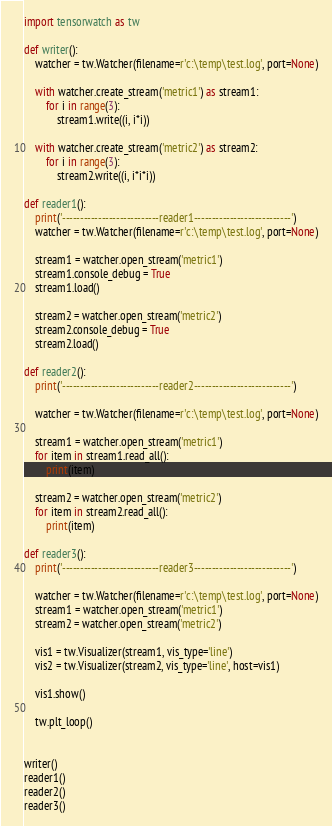Convert code to text. <code><loc_0><loc_0><loc_500><loc_500><_Python_>import tensorwatch as tw

def writer():
    watcher = tw.Watcher(filename=r'c:\temp\test.log', port=None)

    with watcher.create_stream('metric1') as stream1:
        for i in range(3):
            stream1.write((i, i*i))

    with watcher.create_stream('metric2') as stream2:
        for i in range(3):
            stream2.write((i, i*i*i))

def reader1():
    print('---------------------------reader1---------------------------')
    watcher = tw.Watcher(filename=r'c:\temp\test.log', port=None)

    stream1 = watcher.open_stream('metric1')
    stream1.console_debug = True
    stream1.load()

    stream2 = watcher.open_stream('metric2')
    stream2.console_debug = True
    stream2.load()

def reader2():
    print('---------------------------reader2---------------------------')

    watcher = tw.Watcher(filename=r'c:\temp\test.log', port=None)

    stream1 = watcher.open_stream('metric1')
    for item in stream1.read_all():
        print(item)

    stream2 = watcher.open_stream('metric2')
    for item in stream2.read_all():
        print(item)

def reader3():
    print('---------------------------reader3---------------------------')

    watcher = tw.Watcher(filename=r'c:\temp\test.log', port=None)
    stream1 = watcher.open_stream('metric1')
    stream2 = watcher.open_stream('metric2')

    vis1 = tw.Visualizer(stream1, vis_type='line')
    vis2 = tw.Visualizer(stream2, vis_type='line', host=vis1)

    vis1.show()

    tw.plt_loop()


writer()
reader1()
reader2()
reader3()

</code> 